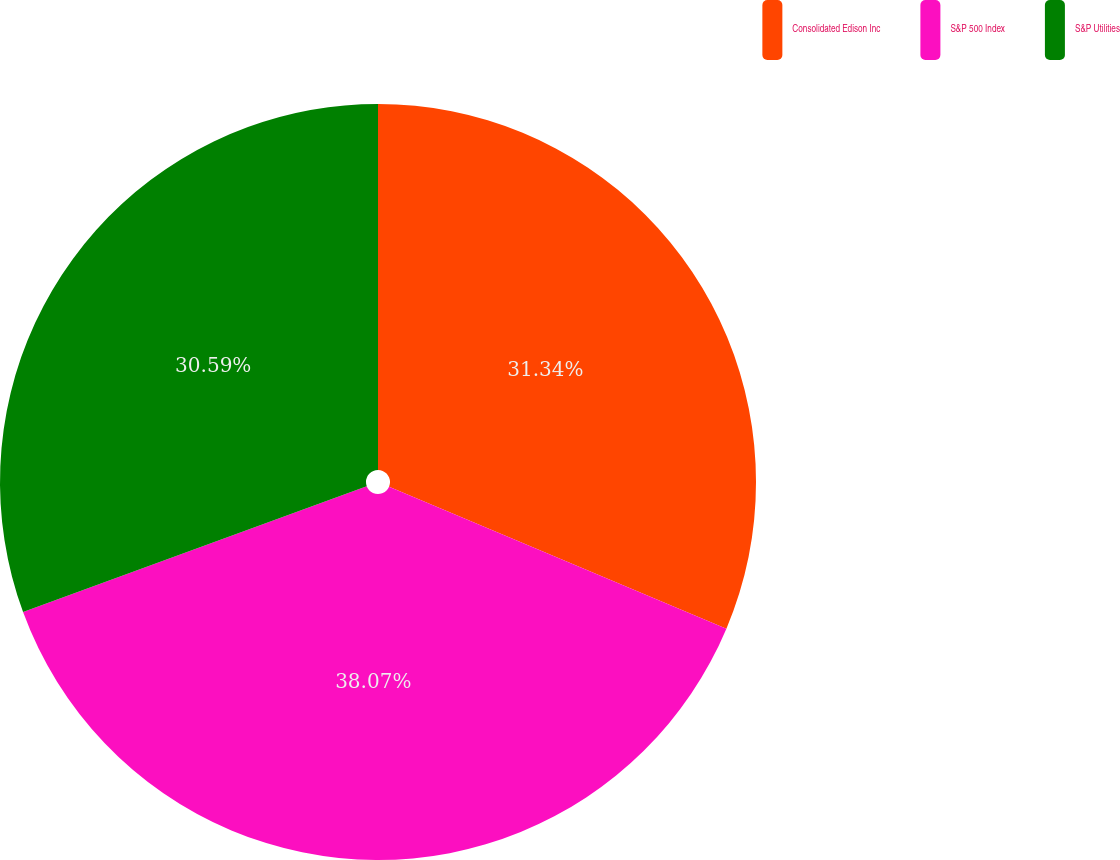Convert chart to OTSL. <chart><loc_0><loc_0><loc_500><loc_500><pie_chart><fcel>Consolidated Edison Inc<fcel>S&P 500 Index<fcel>S&P Utilities<nl><fcel>31.34%<fcel>38.07%<fcel>30.59%<nl></chart> 